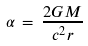Convert formula to latex. <formula><loc_0><loc_0><loc_500><loc_500>\alpha \, = \, \frac { 2 G M } { c ^ { 2 } r }</formula> 